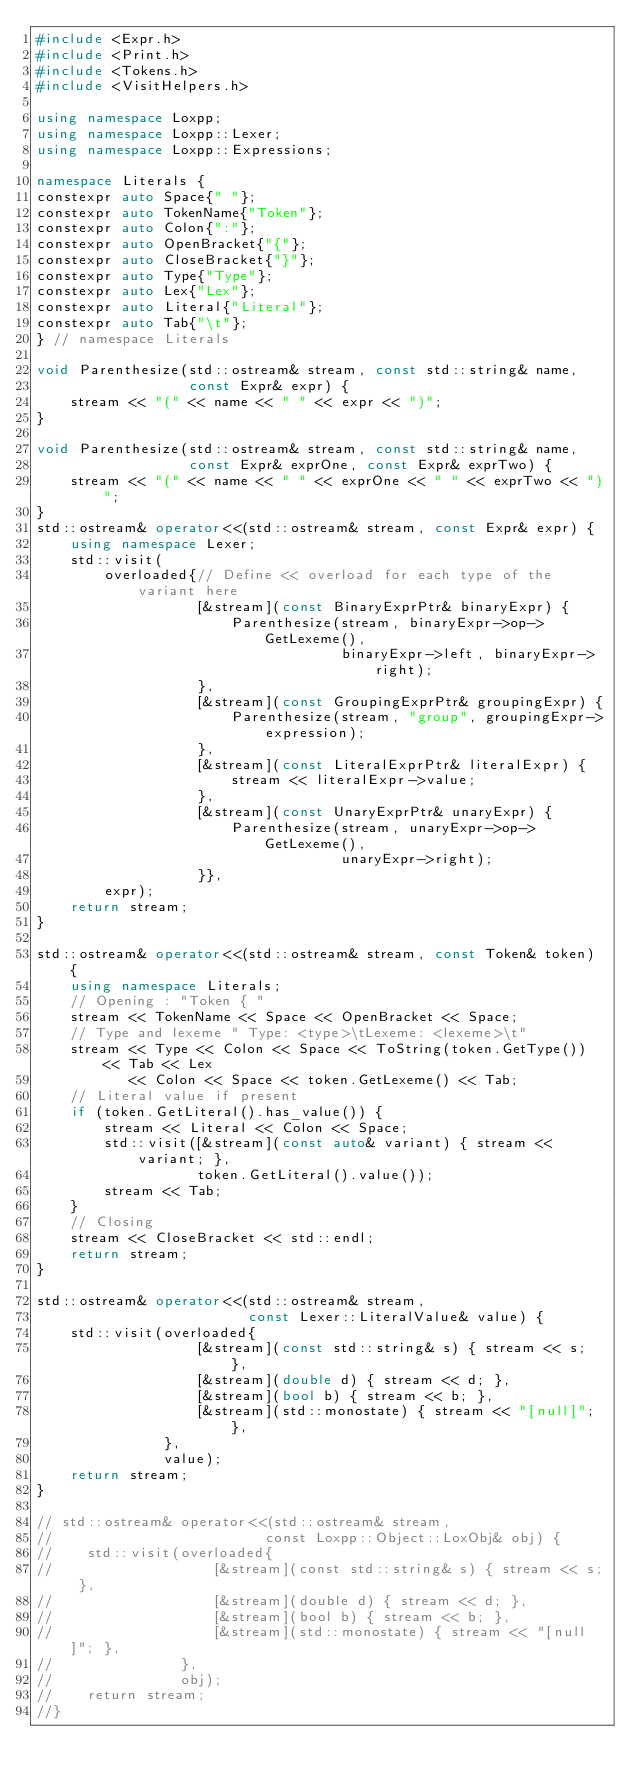Convert code to text. <code><loc_0><loc_0><loc_500><loc_500><_C++_>#include <Expr.h>
#include <Print.h>
#include <Tokens.h>
#include <VisitHelpers.h>

using namespace Loxpp;
using namespace Loxpp::Lexer;
using namespace Loxpp::Expressions;

namespace Literals {
constexpr auto Space{" "};
constexpr auto TokenName{"Token"};
constexpr auto Colon{":"};
constexpr auto OpenBracket{"{"};
constexpr auto CloseBracket{"}"};
constexpr auto Type{"Type"};
constexpr auto Lex{"Lex"};
constexpr auto Literal{"Literal"};
constexpr auto Tab{"\t"};
} // namespace Literals

void Parenthesize(std::ostream& stream, const std::string& name,
                  const Expr& expr) {
    stream << "(" << name << " " << expr << ")";
}

void Parenthesize(std::ostream& stream, const std::string& name,
                  const Expr& exprOne, const Expr& exprTwo) {
    stream << "(" << name << " " << exprOne << " " << exprTwo << ")";
}
std::ostream& operator<<(std::ostream& stream, const Expr& expr) {
    using namespace Lexer;
    std::visit(
        overloaded{// Define << overload for each type of the variant here
                   [&stream](const BinaryExprPtr& binaryExpr) {
                       Parenthesize(stream, binaryExpr->op->GetLexeme(),
                                    binaryExpr->left, binaryExpr->right);
                   },
                   [&stream](const GroupingExprPtr& groupingExpr) {
                       Parenthesize(stream, "group", groupingExpr->expression);
                   },
                   [&stream](const LiteralExprPtr& literalExpr) {
                       stream << literalExpr->value;
                   },
                   [&stream](const UnaryExprPtr& unaryExpr) {
                       Parenthesize(stream, unaryExpr->op->GetLexeme(),
                                    unaryExpr->right);
                   }},
        expr);
    return stream;
}

std::ostream& operator<<(std::ostream& stream, const Token& token) {
    using namespace Literals;
    // Opening : "Token { "
    stream << TokenName << Space << OpenBracket << Space;
    // Type and lexeme " Type: <type>\tLexeme: <lexeme>\t"
    stream << Type << Colon << Space << ToString(token.GetType()) << Tab << Lex
           << Colon << Space << token.GetLexeme() << Tab;
    // Literal value if present
    if (token.GetLiteral().has_value()) {
        stream << Literal << Colon << Space;
        std::visit([&stream](const auto& variant) { stream << variant; },
                   token.GetLiteral().value());
        stream << Tab;
    }
    // Closing
    stream << CloseBracket << std::endl;
    return stream;
}

std::ostream& operator<<(std::ostream& stream,
                         const Lexer::LiteralValue& value) {
    std::visit(overloaded{
                   [&stream](const std::string& s) { stream << s; },
                   [&stream](double d) { stream << d; },
                   [&stream](bool b) { stream << b; },
                   [&stream](std::monostate) { stream << "[null]"; },
               },
               value);
    return stream;
}

// std::ostream& operator<<(std::ostream& stream,
//                         const Loxpp::Object::LoxObj& obj) {
//    std::visit(overloaded{
//                   [&stream](const std::string& s) { stream << s; },
//                   [&stream](double d) { stream << d; },
//                   [&stream](bool b) { stream << b; },
//                   [&stream](std::monostate) { stream << "[null]"; },
//               },
//               obj);
//    return stream;
//}
</code> 